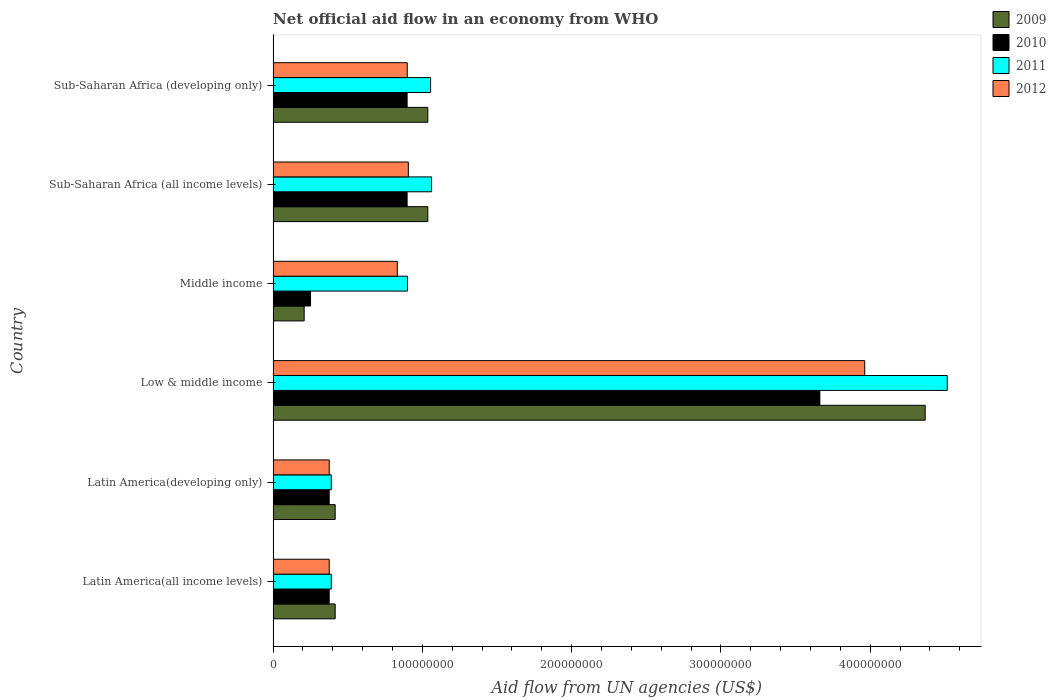How many different coloured bars are there?
Give a very brief answer. 4. How many groups of bars are there?
Ensure brevity in your answer.  6. Are the number of bars on each tick of the Y-axis equal?
Make the answer very short. Yes. How many bars are there on the 2nd tick from the bottom?
Your answer should be very brief. 4. What is the label of the 1st group of bars from the top?
Make the answer very short. Sub-Saharan Africa (developing only). What is the net official aid flow in 2010 in Latin America(developing only)?
Make the answer very short. 3.76e+07. Across all countries, what is the maximum net official aid flow in 2009?
Offer a very short reply. 4.37e+08. Across all countries, what is the minimum net official aid flow in 2010?
Ensure brevity in your answer.  2.51e+07. In which country was the net official aid flow in 2012 maximum?
Your response must be concise. Low & middle income. What is the total net official aid flow in 2010 in the graph?
Offer a very short reply. 6.46e+08. What is the difference between the net official aid flow in 2012 in Latin America(all income levels) and the net official aid flow in 2010 in Sub-Saharan Africa (developing only)?
Your answer should be very brief. -5.22e+07. What is the average net official aid flow in 2011 per country?
Offer a very short reply. 1.39e+08. What is the difference between the net official aid flow in 2011 and net official aid flow in 2009 in Latin America(developing only)?
Your response must be concise. -2.59e+06. In how many countries, is the net official aid flow in 2011 greater than 160000000 US$?
Your answer should be compact. 1. What is the ratio of the net official aid flow in 2009 in Latin America(all income levels) to that in Middle income?
Offer a terse response. 2. Is the net official aid flow in 2009 in Middle income less than that in Sub-Saharan Africa (all income levels)?
Provide a succinct answer. Yes. Is the difference between the net official aid flow in 2011 in Middle income and Sub-Saharan Africa (all income levels) greater than the difference between the net official aid flow in 2009 in Middle income and Sub-Saharan Africa (all income levels)?
Provide a succinct answer. Yes. What is the difference between the highest and the second highest net official aid flow in 2011?
Provide a succinct answer. 3.45e+08. What is the difference between the highest and the lowest net official aid flow in 2010?
Offer a terse response. 3.41e+08. Is it the case that in every country, the sum of the net official aid flow in 2009 and net official aid flow in 2010 is greater than the net official aid flow in 2012?
Your answer should be very brief. No. How many bars are there?
Offer a terse response. 24. Are all the bars in the graph horizontal?
Ensure brevity in your answer.  Yes. How many countries are there in the graph?
Provide a short and direct response. 6. What is the difference between two consecutive major ticks on the X-axis?
Provide a succinct answer. 1.00e+08. Are the values on the major ticks of X-axis written in scientific E-notation?
Give a very brief answer. No. Does the graph contain any zero values?
Ensure brevity in your answer.  No. Does the graph contain grids?
Provide a succinct answer. No. Where does the legend appear in the graph?
Your answer should be very brief. Top right. How many legend labels are there?
Provide a short and direct response. 4. How are the legend labels stacked?
Offer a terse response. Vertical. What is the title of the graph?
Give a very brief answer. Net official aid flow in an economy from WHO. Does "2006" appear as one of the legend labels in the graph?
Provide a short and direct response. No. What is the label or title of the X-axis?
Provide a short and direct response. Aid flow from UN agencies (US$). What is the label or title of the Y-axis?
Keep it short and to the point. Country. What is the Aid flow from UN agencies (US$) in 2009 in Latin America(all income levels)?
Make the answer very short. 4.16e+07. What is the Aid flow from UN agencies (US$) in 2010 in Latin America(all income levels)?
Your response must be concise. 3.76e+07. What is the Aid flow from UN agencies (US$) of 2011 in Latin America(all income levels)?
Give a very brief answer. 3.90e+07. What is the Aid flow from UN agencies (US$) in 2012 in Latin America(all income levels)?
Offer a terse response. 3.76e+07. What is the Aid flow from UN agencies (US$) in 2009 in Latin America(developing only)?
Keep it short and to the point. 4.16e+07. What is the Aid flow from UN agencies (US$) in 2010 in Latin America(developing only)?
Your answer should be compact. 3.76e+07. What is the Aid flow from UN agencies (US$) of 2011 in Latin America(developing only)?
Your answer should be very brief. 3.90e+07. What is the Aid flow from UN agencies (US$) of 2012 in Latin America(developing only)?
Offer a terse response. 3.76e+07. What is the Aid flow from UN agencies (US$) in 2009 in Low & middle income?
Your response must be concise. 4.37e+08. What is the Aid flow from UN agencies (US$) in 2010 in Low & middle income?
Keep it short and to the point. 3.66e+08. What is the Aid flow from UN agencies (US$) in 2011 in Low & middle income?
Keep it short and to the point. 4.52e+08. What is the Aid flow from UN agencies (US$) in 2012 in Low & middle income?
Provide a short and direct response. 3.96e+08. What is the Aid flow from UN agencies (US$) of 2009 in Middle income?
Provide a short and direct response. 2.08e+07. What is the Aid flow from UN agencies (US$) in 2010 in Middle income?
Offer a terse response. 2.51e+07. What is the Aid flow from UN agencies (US$) in 2011 in Middle income?
Give a very brief answer. 9.00e+07. What is the Aid flow from UN agencies (US$) in 2012 in Middle income?
Ensure brevity in your answer.  8.32e+07. What is the Aid flow from UN agencies (US$) in 2009 in Sub-Saharan Africa (all income levels)?
Keep it short and to the point. 1.04e+08. What is the Aid flow from UN agencies (US$) in 2010 in Sub-Saharan Africa (all income levels)?
Keep it short and to the point. 8.98e+07. What is the Aid flow from UN agencies (US$) of 2011 in Sub-Saharan Africa (all income levels)?
Your response must be concise. 1.06e+08. What is the Aid flow from UN agencies (US$) of 2012 in Sub-Saharan Africa (all income levels)?
Make the answer very short. 9.06e+07. What is the Aid flow from UN agencies (US$) of 2009 in Sub-Saharan Africa (developing only)?
Give a very brief answer. 1.04e+08. What is the Aid flow from UN agencies (US$) in 2010 in Sub-Saharan Africa (developing only)?
Your answer should be compact. 8.98e+07. What is the Aid flow from UN agencies (US$) in 2011 in Sub-Saharan Africa (developing only)?
Make the answer very short. 1.05e+08. What is the Aid flow from UN agencies (US$) in 2012 in Sub-Saharan Africa (developing only)?
Offer a very short reply. 8.98e+07. Across all countries, what is the maximum Aid flow from UN agencies (US$) in 2009?
Offer a very short reply. 4.37e+08. Across all countries, what is the maximum Aid flow from UN agencies (US$) of 2010?
Keep it short and to the point. 3.66e+08. Across all countries, what is the maximum Aid flow from UN agencies (US$) of 2011?
Your answer should be compact. 4.52e+08. Across all countries, what is the maximum Aid flow from UN agencies (US$) in 2012?
Provide a short and direct response. 3.96e+08. Across all countries, what is the minimum Aid flow from UN agencies (US$) of 2009?
Offer a very short reply. 2.08e+07. Across all countries, what is the minimum Aid flow from UN agencies (US$) in 2010?
Your answer should be compact. 2.51e+07. Across all countries, what is the minimum Aid flow from UN agencies (US$) of 2011?
Provide a short and direct response. 3.90e+07. Across all countries, what is the minimum Aid flow from UN agencies (US$) of 2012?
Your response must be concise. 3.76e+07. What is the total Aid flow from UN agencies (US$) of 2009 in the graph?
Your answer should be compact. 7.48e+08. What is the total Aid flow from UN agencies (US$) in 2010 in the graph?
Your response must be concise. 6.46e+08. What is the total Aid flow from UN agencies (US$) of 2011 in the graph?
Provide a short and direct response. 8.31e+08. What is the total Aid flow from UN agencies (US$) in 2012 in the graph?
Your answer should be very brief. 7.35e+08. What is the difference between the Aid flow from UN agencies (US$) of 2010 in Latin America(all income levels) and that in Latin America(developing only)?
Keep it short and to the point. 0. What is the difference between the Aid flow from UN agencies (US$) in 2012 in Latin America(all income levels) and that in Latin America(developing only)?
Offer a terse response. 0. What is the difference between the Aid flow from UN agencies (US$) in 2009 in Latin America(all income levels) and that in Low & middle income?
Make the answer very short. -3.95e+08. What is the difference between the Aid flow from UN agencies (US$) of 2010 in Latin America(all income levels) and that in Low & middle income?
Make the answer very short. -3.29e+08. What is the difference between the Aid flow from UN agencies (US$) in 2011 in Latin America(all income levels) and that in Low & middle income?
Offer a very short reply. -4.13e+08. What is the difference between the Aid flow from UN agencies (US$) in 2012 in Latin America(all income levels) and that in Low & middle income?
Your answer should be compact. -3.59e+08. What is the difference between the Aid flow from UN agencies (US$) of 2009 in Latin America(all income levels) and that in Middle income?
Provide a short and direct response. 2.08e+07. What is the difference between the Aid flow from UN agencies (US$) in 2010 in Latin America(all income levels) and that in Middle income?
Ensure brevity in your answer.  1.25e+07. What is the difference between the Aid flow from UN agencies (US$) of 2011 in Latin America(all income levels) and that in Middle income?
Give a very brief answer. -5.10e+07. What is the difference between the Aid flow from UN agencies (US$) in 2012 in Latin America(all income levels) and that in Middle income?
Your answer should be compact. -4.56e+07. What is the difference between the Aid flow from UN agencies (US$) of 2009 in Latin America(all income levels) and that in Sub-Saharan Africa (all income levels)?
Make the answer very short. -6.20e+07. What is the difference between the Aid flow from UN agencies (US$) in 2010 in Latin America(all income levels) and that in Sub-Saharan Africa (all income levels)?
Provide a succinct answer. -5.22e+07. What is the difference between the Aid flow from UN agencies (US$) in 2011 in Latin America(all income levels) and that in Sub-Saharan Africa (all income levels)?
Your response must be concise. -6.72e+07. What is the difference between the Aid flow from UN agencies (US$) of 2012 in Latin America(all income levels) and that in Sub-Saharan Africa (all income levels)?
Make the answer very short. -5.30e+07. What is the difference between the Aid flow from UN agencies (US$) in 2009 in Latin America(all income levels) and that in Sub-Saharan Africa (developing only)?
Offer a terse response. -6.20e+07. What is the difference between the Aid flow from UN agencies (US$) of 2010 in Latin America(all income levels) and that in Sub-Saharan Africa (developing only)?
Make the answer very short. -5.22e+07. What is the difference between the Aid flow from UN agencies (US$) of 2011 in Latin America(all income levels) and that in Sub-Saharan Africa (developing only)?
Provide a short and direct response. -6.65e+07. What is the difference between the Aid flow from UN agencies (US$) in 2012 in Latin America(all income levels) and that in Sub-Saharan Africa (developing only)?
Ensure brevity in your answer.  -5.23e+07. What is the difference between the Aid flow from UN agencies (US$) in 2009 in Latin America(developing only) and that in Low & middle income?
Provide a short and direct response. -3.95e+08. What is the difference between the Aid flow from UN agencies (US$) in 2010 in Latin America(developing only) and that in Low & middle income?
Your answer should be very brief. -3.29e+08. What is the difference between the Aid flow from UN agencies (US$) of 2011 in Latin America(developing only) and that in Low & middle income?
Keep it short and to the point. -4.13e+08. What is the difference between the Aid flow from UN agencies (US$) of 2012 in Latin America(developing only) and that in Low & middle income?
Provide a short and direct response. -3.59e+08. What is the difference between the Aid flow from UN agencies (US$) in 2009 in Latin America(developing only) and that in Middle income?
Provide a short and direct response. 2.08e+07. What is the difference between the Aid flow from UN agencies (US$) of 2010 in Latin America(developing only) and that in Middle income?
Ensure brevity in your answer.  1.25e+07. What is the difference between the Aid flow from UN agencies (US$) of 2011 in Latin America(developing only) and that in Middle income?
Give a very brief answer. -5.10e+07. What is the difference between the Aid flow from UN agencies (US$) of 2012 in Latin America(developing only) and that in Middle income?
Provide a short and direct response. -4.56e+07. What is the difference between the Aid flow from UN agencies (US$) of 2009 in Latin America(developing only) and that in Sub-Saharan Africa (all income levels)?
Keep it short and to the point. -6.20e+07. What is the difference between the Aid flow from UN agencies (US$) in 2010 in Latin America(developing only) and that in Sub-Saharan Africa (all income levels)?
Provide a short and direct response. -5.22e+07. What is the difference between the Aid flow from UN agencies (US$) of 2011 in Latin America(developing only) and that in Sub-Saharan Africa (all income levels)?
Make the answer very short. -6.72e+07. What is the difference between the Aid flow from UN agencies (US$) of 2012 in Latin America(developing only) and that in Sub-Saharan Africa (all income levels)?
Offer a terse response. -5.30e+07. What is the difference between the Aid flow from UN agencies (US$) of 2009 in Latin America(developing only) and that in Sub-Saharan Africa (developing only)?
Provide a succinct answer. -6.20e+07. What is the difference between the Aid flow from UN agencies (US$) in 2010 in Latin America(developing only) and that in Sub-Saharan Africa (developing only)?
Provide a succinct answer. -5.22e+07. What is the difference between the Aid flow from UN agencies (US$) of 2011 in Latin America(developing only) and that in Sub-Saharan Africa (developing only)?
Offer a terse response. -6.65e+07. What is the difference between the Aid flow from UN agencies (US$) of 2012 in Latin America(developing only) and that in Sub-Saharan Africa (developing only)?
Ensure brevity in your answer.  -5.23e+07. What is the difference between the Aid flow from UN agencies (US$) of 2009 in Low & middle income and that in Middle income?
Ensure brevity in your answer.  4.16e+08. What is the difference between the Aid flow from UN agencies (US$) in 2010 in Low & middle income and that in Middle income?
Ensure brevity in your answer.  3.41e+08. What is the difference between the Aid flow from UN agencies (US$) of 2011 in Low & middle income and that in Middle income?
Give a very brief answer. 3.62e+08. What is the difference between the Aid flow from UN agencies (US$) of 2012 in Low & middle income and that in Middle income?
Provide a succinct answer. 3.13e+08. What is the difference between the Aid flow from UN agencies (US$) in 2009 in Low & middle income and that in Sub-Saharan Africa (all income levels)?
Ensure brevity in your answer.  3.33e+08. What is the difference between the Aid flow from UN agencies (US$) of 2010 in Low & middle income and that in Sub-Saharan Africa (all income levels)?
Ensure brevity in your answer.  2.76e+08. What is the difference between the Aid flow from UN agencies (US$) in 2011 in Low & middle income and that in Sub-Saharan Africa (all income levels)?
Offer a very short reply. 3.45e+08. What is the difference between the Aid flow from UN agencies (US$) of 2012 in Low & middle income and that in Sub-Saharan Africa (all income levels)?
Ensure brevity in your answer.  3.06e+08. What is the difference between the Aid flow from UN agencies (US$) of 2009 in Low & middle income and that in Sub-Saharan Africa (developing only)?
Your answer should be very brief. 3.33e+08. What is the difference between the Aid flow from UN agencies (US$) of 2010 in Low & middle income and that in Sub-Saharan Africa (developing only)?
Offer a very short reply. 2.76e+08. What is the difference between the Aid flow from UN agencies (US$) of 2011 in Low & middle income and that in Sub-Saharan Africa (developing only)?
Give a very brief answer. 3.46e+08. What is the difference between the Aid flow from UN agencies (US$) in 2012 in Low & middle income and that in Sub-Saharan Africa (developing only)?
Keep it short and to the point. 3.06e+08. What is the difference between the Aid flow from UN agencies (US$) of 2009 in Middle income and that in Sub-Saharan Africa (all income levels)?
Provide a succinct answer. -8.28e+07. What is the difference between the Aid flow from UN agencies (US$) of 2010 in Middle income and that in Sub-Saharan Africa (all income levels)?
Provide a short and direct response. -6.47e+07. What is the difference between the Aid flow from UN agencies (US$) in 2011 in Middle income and that in Sub-Saharan Africa (all income levels)?
Your answer should be very brief. -1.62e+07. What is the difference between the Aid flow from UN agencies (US$) of 2012 in Middle income and that in Sub-Saharan Africa (all income levels)?
Make the answer very short. -7.39e+06. What is the difference between the Aid flow from UN agencies (US$) of 2009 in Middle income and that in Sub-Saharan Africa (developing only)?
Give a very brief answer. -8.28e+07. What is the difference between the Aid flow from UN agencies (US$) of 2010 in Middle income and that in Sub-Saharan Africa (developing only)?
Offer a terse response. -6.47e+07. What is the difference between the Aid flow from UN agencies (US$) in 2011 in Middle income and that in Sub-Saharan Africa (developing only)?
Provide a succinct answer. -1.55e+07. What is the difference between the Aid flow from UN agencies (US$) of 2012 in Middle income and that in Sub-Saharan Africa (developing only)?
Provide a short and direct response. -6.67e+06. What is the difference between the Aid flow from UN agencies (US$) in 2011 in Sub-Saharan Africa (all income levels) and that in Sub-Saharan Africa (developing only)?
Give a very brief answer. 6.70e+05. What is the difference between the Aid flow from UN agencies (US$) in 2012 in Sub-Saharan Africa (all income levels) and that in Sub-Saharan Africa (developing only)?
Ensure brevity in your answer.  7.20e+05. What is the difference between the Aid flow from UN agencies (US$) of 2009 in Latin America(all income levels) and the Aid flow from UN agencies (US$) of 2010 in Latin America(developing only)?
Give a very brief answer. 4.01e+06. What is the difference between the Aid flow from UN agencies (US$) in 2009 in Latin America(all income levels) and the Aid flow from UN agencies (US$) in 2011 in Latin America(developing only)?
Your answer should be compact. 2.59e+06. What is the difference between the Aid flow from UN agencies (US$) in 2009 in Latin America(all income levels) and the Aid flow from UN agencies (US$) in 2012 in Latin America(developing only)?
Offer a terse response. 3.99e+06. What is the difference between the Aid flow from UN agencies (US$) of 2010 in Latin America(all income levels) and the Aid flow from UN agencies (US$) of 2011 in Latin America(developing only)?
Your response must be concise. -1.42e+06. What is the difference between the Aid flow from UN agencies (US$) of 2011 in Latin America(all income levels) and the Aid flow from UN agencies (US$) of 2012 in Latin America(developing only)?
Your response must be concise. 1.40e+06. What is the difference between the Aid flow from UN agencies (US$) in 2009 in Latin America(all income levels) and the Aid flow from UN agencies (US$) in 2010 in Low & middle income?
Your response must be concise. -3.25e+08. What is the difference between the Aid flow from UN agencies (US$) in 2009 in Latin America(all income levels) and the Aid flow from UN agencies (US$) in 2011 in Low & middle income?
Offer a terse response. -4.10e+08. What is the difference between the Aid flow from UN agencies (US$) of 2009 in Latin America(all income levels) and the Aid flow from UN agencies (US$) of 2012 in Low & middle income?
Ensure brevity in your answer.  -3.55e+08. What is the difference between the Aid flow from UN agencies (US$) in 2010 in Latin America(all income levels) and the Aid flow from UN agencies (US$) in 2011 in Low & middle income?
Offer a terse response. -4.14e+08. What is the difference between the Aid flow from UN agencies (US$) of 2010 in Latin America(all income levels) and the Aid flow from UN agencies (US$) of 2012 in Low & middle income?
Offer a very short reply. -3.59e+08. What is the difference between the Aid flow from UN agencies (US$) of 2011 in Latin America(all income levels) and the Aid flow from UN agencies (US$) of 2012 in Low & middle income?
Your answer should be compact. -3.57e+08. What is the difference between the Aid flow from UN agencies (US$) in 2009 in Latin America(all income levels) and the Aid flow from UN agencies (US$) in 2010 in Middle income?
Ensure brevity in your answer.  1.65e+07. What is the difference between the Aid flow from UN agencies (US$) in 2009 in Latin America(all income levels) and the Aid flow from UN agencies (US$) in 2011 in Middle income?
Give a very brief answer. -4.84e+07. What is the difference between the Aid flow from UN agencies (US$) of 2009 in Latin America(all income levels) and the Aid flow from UN agencies (US$) of 2012 in Middle income?
Your response must be concise. -4.16e+07. What is the difference between the Aid flow from UN agencies (US$) of 2010 in Latin America(all income levels) and the Aid flow from UN agencies (US$) of 2011 in Middle income?
Your answer should be very brief. -5.24e+07. What is the difference between the Aid flow from UN agencies (US$) in 2010 in Latin America(all income levels) and the Aid flow from UN agencies (US$) in 2012 in Middle income?
Your answer should be compact. -4.56e+07. What is the difference between the Aid flow from UN agencies (US$) of 2011 in Latin America(all income levels) and the Aid flow from UN agencies (US$) of 2012 in Middle income?
Provide a short and direct response. -4.42e+07. What is the difference between the Aid flow from UN agencies (US$) in 2009 in Latin America(all income levels) and the Aid flow from UN agencies (US$) in 2010 in Sub-Saharan Africa (all income levels)?
Keep it short and to the point. -4.82e+07. What is the difference between the Aid flow from UN agencies (US$) of 2009 in Latin America(all income levels) and the Aid flow from UN agencies (US$) of 2011 in Sub-Saharan Africa (all income levels)?
Your response must be concise. -6.46e+07. What is the difference between the Aid flow from UN agencies (US$) in 2009 in Latin America(all income levels) and the Aid flow from UN agencies (US$) in 2012 in Sub-Saharan Africa (all income levels)?
Provide a short and direct response. -4.90e+07. What is the difference between the Aid flow from UN agencies (US$) of 2010 in Latin America(all income levels) and the Aid flow from UN agencies (US$) of 2011 in Sub-Saharan Africa (all income levels)?
Provide a short and direct response. -6.86e+07. What is the difference between the Aid flow from UN agencies (US$) of 2010 in Latin America(all income levels) and the Aid flow from UN agencies (US$) of 2012 in Sub-Saharan Africa (all income levels)?
Your response must be concise. -5.30e+07. What is the difference between the Aid flow from UN agencies (US$) in 2011 in Latin America(all income levels) and the Aid flow from UN agencies (US$) in 2012 in Sub-Saharan Africa (all income levels)?
Give a very brief answer. -5.16e+07. What is the difference between the Aid flow from UN agencies (US$) of 2009 in Latin America(all income levels) and the Aid flow from UN agencies (US$) of 2010 in Sub-Saharan Africa (developing only)?
Offer a very short reply. -4.82e+07. What is the difference between the Aid flow from UN agencies (US$) in 2009 in Latin America(all income levels) and the Aid flow from UN agencies (US$) in 2011 in Sub-Saharan Africa (developing only)?
Offer a terse response. -6.39e+07. What is the difference between the Aid flow from UN agencies (US$) of 2009 in Latin America(all income levels) and the Aid flow from UN agencies (US$) of 2012 in Sub-Saharan Africa (developing only)?
Provide a succinct answer. -4.83e+07. What is the difference between the Aid flow from UN agencies (US$) of 2010 in Latin America(all income levels) and the Aid flow from UN agencies (US$) of 2011 in Sub-Saharan Africa (developing only)?
Ensure brevity in your answer.  -6.79e+07. What is the difference between the Aid flow from UN agencies (US$) in 2010 in Latin America(all income levels) and the Aid flow from UN agencies (US$) in 2012 in Sub-Saharan Africa (developing only)?
Your answer should be compact. -5.23e+07. What is the difference between the Aid flow from UN agencies (US$) of 2011 in Latin America(all income levels) and the Aid flow from UN agencies (US$) of 2012 in Sub-Saharan Africa (developing only)?
Give a very brief answer. -5.09e+07. What is the difference between the Aid flow from UN agencies (US$) of 2009 in Latin America(developing only) and the Aid flow from UN agencies (US$) of 2010 in Low & middle income?
Keep it short and to the point. -3.25e+08. What is the difference between the Aid flow from UN agencies (US$) in 2009 in Latin America(developing only) and the Aid flow from UN agencies (US$) in 2011 in Low & middle income?
Make the answer very short. -4.10e+08. What is the difference between the Aid flow from UN agencies (US$) of 2009 in Latin America(developing only) and the Aid flow from UN agencies (US$) of 2012 in Low & middle income?
Provide a short and direct response. -3.55e+08. What is the difference between the Aid flow from UN agencies (US$) in 2010 in Latin America(developing only) and the Aid flow from UN agencies (US$) in 2011 in Low & middle income?
Offer a very short reply. -4.14e+08. What is the difference between the Aid flow from UN agencies (US$) in 2010 in Latin America(developing only) and the Aid flow from UN agencies (US$) in 2012 in Low & middle income?
Your response must be concise. -3.59e+08. What is the difference between the Aid flow from UN agencies (US$) in 2011 in Latin America(developing only) and the Aid flow from UN agencies (US$) in 2012 in Low & middle income?
Provide a short and direct response. -3.57e+08. What is the difference between the Aid flow from UN agencies (US$) in 2009 in Latin America(developing only) and the Aid flow from UN agencies (US$) in 2010 in Middle income?
Provide a succinct answer. 1.65e+07. What is the difference between the Aid flow from UN agencies (US$) in 2009 in Latin America(developing only) and the Aid flow from UN agencies (US$) in 2011 in Middle income?
Make the answer very short. -4.84e+07. What is the difference between the Aid flow from UN agencies (US$) in 2009 in Latin America(developing only) and the Aid flow from UN agencies (US$) in 2012 in Middle income?
Offer a terse response. -4.16e+07. What is the difference between the Aid flow from UN agencies (US$) in 2010 in Latin America(developing only) and the Aid flow from UN agencies (US$) in 2011 in Middle income?
Your answer should be compact. -5.24e+07. What is the difference between the Aid flow from UN agencies (US$) of 2010 in Latin America(developing only) and the Aid flow from UN agencies (US$) of 2012 in Middle income?
Offer a very short reply. -4.56e+07. What is the difference between the Aid flow from UN agencies (US$) in 2011 in Latin America(developing only) and the Aid flow from UN agencies (US$) in 2012 in Middle income?
Your answer should be compact. -4.42e+07. What is the difference between the Aid flow from UN agencies (US$) of 2009 in Latin America(developing only) and the Aid flow from UN agencies (US$) of 2010 in Sub-Saharan Africa (all income levels)?
Ensure brevity in your answer.  -4.82e+07. What is the difference between the Aid flow from UN agencies (US$) in 2009 in Latin America(developing only) and the Aid flow from UN agencies (US$) in 2011 in Sub-Saharan Africa (all income levels)?
Offer a very short reply. -6.46e+07. What is the difference between the Aid flow from UN agencies (US$) in 2009 in Latin America(developing only) and the Aid flow from UN agencies (US$) in 2012 in Sub-Saharan Africa (all income levels)?
Offer a very short reply. -4.90e+07. What is the difference between the Aid flow from UN agencies (US$) in 2010 in Latin America(developing only) and the Aid flow from UN agencies (US$) in 2011 in Sub-Saharan Africa (all income levels)?
Your answer should be compact. -6.86e+07. What is the difference between the Aid flow from UN agencies (US$) of 2010 in Latin America(developing only) and the Aid flow from UN agencies (US$) of 2012 in Sub-Saharan Africa (all income levels)?
Keep it short and to the point. -5.30e+07. What is the difference between the Aid flow from UN agencies (US$) of 2011 in Latin America(developing only) and the Aid flow from UN agencies (US$) of 2012 in Sub-Saharan Africa (all income levels)?
Offer a terse response. -5.16e+07. What is the difference between the Aid flow from UN agencies (US$) in 2009 in Latin America(developing only) and the Aid flow from UN agencies (US$) in 2010 in Sub-Saharan Africa (developing only)?
Make the answer very short. -4.82e+07. What is the difference between the Aid flow from UN agencies (US$) of 2009 in Latin America(developing only) and the Aid flow from UN agencies (US$) of 2011 in Sub-Saharan Africa (developing only)?
Keep it short and to the point. -6.39e+07. What is the difference between the Aid flow from UN agencies (US$) in 2009 in Latin America(developing only) and the Aid flow from UN agencies (US$) in 2012 in Sub-Saharan Africa (developing only)?
Provide a succinct answer. -4.83e+07. What is the difference between the Aid flow from UN agencies (US$) in 2010 in Latin America(developing only) and the Aid flow from UN agencies (US$) in 2011 in Sub-Saharan Africa (developing only)?
Give a very brief answer. -6.79e+07. What is the difference between the Aid flow from UN agencies (US$) of 2010 in Latin America(developing only) and the Aid flow from UN agencies (US$) of 2012 in Sub-Saharan Africa (developing only)?
Keep it short and to the point. -5.23e+07. What is the difference between the Aid flow from UN agencies (US$) of 2011 in Latin America(developing only) and the Aid flow from UN agencies (US$) of 2012 in Sub-Saharan Africa (developing only)?
Offer a very short reply. -5.09e+07. What is the difference between the Aid flow from UN agencies (US$) of 2009 in Low & middle income and the Aid flow from UN agencies (US$) of 2010 in Middle income?
Keep it short and to the point. 4.12e+08. What is the difference between the Aid flow from UN agencies (US$) of 2009 in Low & middle income and the Aid flow from UN agencies (US$) of 2011 in Middle income?
Your answer should be very brief. 3.47e+08. What is the difference between the Aid flow from UN agencies (US$) in 2009 in Low & middle income and the Aid flow from UN agencies (US$) in 2012 in Middle income?
Offer a terse response. 3.54e+08. What is the difference between the Aid flow from UN agencies (US$) in 2010 in Low & middle income and the Aid flow from UN agencies (US$) in 2011 in Middle income?
Make the answer very short. 2.76e+08. What is the difference between the Aid flow from UN agencies (US$) of 2010 in Low & middle income and the Aid flow from UN agencies (US$) of 2012 in Middle income?
Your answer should be compact. 2.83e+08. What is the difference between the Aid flow from UN agencies (US$) in 2011 in Low & middle income and the Aid flow from UN agencies (US$) in 2012 in Middle income?
Your answer should be very brief. 3.68e+08. What is the difference between the Aid flow from UN agencies (US$) in 2009 in Low & middle income and the Aid flow from UN agencies (US$) in 2010 in Sub-Saharan Africa (all income levels)?
Your answer should be very brief. 3.47e+08. What is the difference between the Aid flow from UN agencies (US$) in 2009 in Low & middle income and the Aid flow from UN agencies (US$) in 2011 in Sub-Saharan Africa (all income levels)?
Make the answer very short. 3.31e+08. What is the difference between the Aid flow from UN agencies (US$) in 2009 in Low & middle income and the Aid flow from UN agencies (US$) in 2012 in Sub-Saharan Africa (all income levels)?
Offer a very short reply. 3.46e+08. What is the difference between the Aid flow from UN agencies (US$) of 2010 in Low & middle income and the Aid flow from UN agencies (US$) of 2011 in Sub-Saharan Africa (all income levels)?
Keep it short and to the point. 2.60e+08. What is the difference between the Aid flow from UN agencies (US$) of 2010 in Low & middle income and the Aid flow from UN agencies (US$) of 2012 in Sub-Saharan Africa (all income levels)?
Your answer should be very brief. 2.76e+08. What is the difference between the Aid flow from UN agencies (US$) of 2011 in Low & middle income and the Aid flow from UN agencies (US$) of 2012 in Sub-Saharan Africa (all income levels)?
Make the answer very short. 3.61e+08. What is the difference between the Aid flow from UN agencies (US$) in 2009 in Low & middle income and the Aid flow from UN agencies (US$) in 2010 in Sub-Saharan Africa (developing only)?
Keep it short and to the point. 3.47e+08. What is the difference between the Aid flow from UN agencies (US$) in 2009 in Low & middle income and the Aid flow from UN agencies (US$) in 2011 in Sub-Saharan Africa (developing only)?
Offer a terse response. 3.31e+08. What is the difference between the Aid flow from UN agencies (US$) of 2009 in Low & middle income and the Aid flow from UN agencies (US$) of 2012 in Sub-Saharan Africa (developing only)?
Keep it short and to the point. 3.47e+08. What is the difference between the Aid flow from UN agencies (US$) of 2010 in Low & middle income and the Aid flow from UN agencies (US$) of 2011 in Sub-Saharan Africa (developing only)?
Give a very brief answer. 2.61e+08. What is the difference between the Aid flow from UN agencies (US$) in 2010 in Low & middle income and the Aid flow from UN agencies (US$) in 2012 in Sub-Saharan Africa (developing only)?
Provide a short and direct response. 2.76e+08. What is the difference between the Aid flow from UN agencies (US$) in 2011 in Low & middle income and the Aid flow from UN agencies (US$) in 2012 in Sub-Saharan Africa (developing only)?
Offer a terse response. 3.62e+08. What is the difference between the Aid flow from UN agencies (US$) of 2009 in Middle income and the Aid flow from UN agencies (US$) of 2010 in Sub-Saharan Africa (all income levels)?
Ensure brevity in your answer.  -6.90e+07. What is the difference between the Aid flow from UN agencies (US$) in 2009 in Middle income and the Aid flow from UN agencies (US$) in 2011 in Sub-Saharan Africa (all income levels)?
Your response must be concise. -8.54e+07. What is the difference between the Aid flow from UN agencies (US$) in 2009 in Middle income and the Aid flow from UN agencies (US$) in 2012 in Sub-Saharan Africa (all income levels)?
Give a very brief answer. -6.98e+07. What is the difference between the Aid flow from UN agencies (US$) in 2010 in Middle income and the Aid flow from UN agencies (US$) in 2011 in Sub-Saharan Africa (all income levels)?
Provide a succinct answer. -8.11e+07. What is the difference between the Aid flow from UN agencies (US$) in 2010 in Middle income and the Aid flow from UN agencies (US$) in 2012 in Sub-Saharan Africa (all income levels)?
Your response must be concise. -6.55e+07. What is the difference between the Aid flow from UN agencies (US$) of 2011 in Middle income and the Aid flow from UN agencies (US$) of 2012 in Sub-Saharan Africa (all income levels)?
Provide a short and direct response. -5.90e+05. What is the difference between the Aid flow from UN agencies (US$) of 2009 in Middle income and the Aid flow from UN agencies (US$) of 2010 in Sub-Saharan Africa (developing only)?
Give a very brief answer. -6.90e+07. What is the difference between the Aid flow from UN agencies (US$) in 2009 in Middle income and the Aid flow from UN agencies (US$) in 2011 in Sub-Saharan Africa (developing only)?
Ensure brevity in your answer.  -8.47e+07. What is the difference between the Aid flow from UN agencies (US$) of 2009 in Middle income and the Aid flow from UN agencies (US$) of 2012 in Sub-Saharan Africa (developing only)?
Give a very brief answer. -6.90e+07. What is the difference between the Aid flow from UN agencies (US$) of 2010 in Middle income and the Aid flow from UN agencies (US$) of 2011 in Sub-Saharan Africa (developing only)?
Make the answer very short. -8.04e+07. What is the difference between the Aid flow from UN agencies (US$) of 2010 in Middle income and the Aid flow from UN agencies (US$) of 2012 in Sub-Saharan Africa (developing only)?
Keep it short and to the point. -6.48e+07. What is the difference between the Aid flow from UN agencies (US$) in 2011 in Middle income and the Aid flow from UN agencies (US$) in 2012 in Sub-Saharan Africa (developing only)?
Provide a short and direct response. 1.30e+05. What is the difference between the Aid flow from UN agencies (US$) of 2009 in Sub-Saharan Africa (all income levels) and the Aid flow from UN agencies (US$) of 2010 in Sub-Saharan Africa (developing only)?
Keep it short and to the point. 1.39e+07. What is the difference between the Aid flow from UN agencies (US$) of 2009 in Sub-Saharan Africa (all income levels) and the Aid flow from UN agencies (US$) of 2011 in Sub-Saharan Africa (developing only)?
Ensure brevity in your answer.  -1.86e+06. What is the difference between the Aid flow from UN agencies (US$) in 2009 in Sub-Saharan Africa (all income levels) and the Aid flow from UN agencies (US$) in 2012 in Sub-Saharan Africa (developing only)?
Offer a terse response. 1.38e+07. What is the difference between the Aid flow from UN agencies (US$) of 2010 in Sub-Saharan Africa (all income levels) and the Aid flow from UN agencies (US$) of 2011 in Sub-Saharan Africa (developing only)?
Make the answer very short. -1.57e+07. What is the difference between the Aid flow from UN agencies (US$) in 2010 in Sub-Saharan Africa (all income levels) and the Aid flow from UN agencies (US$) in 2012 in Sub-Saharan Africa (developing only)?
Give a very brief answer. -9.00e+04. What is the difference between the Aid flow from UN agencies (US$) in 2011 in Sub-Saharan Africa (all income levels) and the Aid flow from UN agencies (US$) in 2012 in Sub-Saharan Africa (developing only)?
Offer a very short reply. 1.63e+07. What is the average Aid flow from UN agencies (US$) of 2009 per country?
Provide a short and direct response. 1.25e+08. What is the average Aid flow from UN agencies (US$) of 2010 per country?
Offer a very short reply. 1.08e+08. What is the average Aid flow from UN agencies (US$) in 2011 per country?
Ensure brevity in your answer.  1.39e+08. What is the average Aid flow from UN agencies (US$) of 2012 per country?
Provide a short and direct response. 1.23e+08. What is the difference between the Aid flow from UN agencies (US$) in 2009 and Aid flow from UN agencies (US$) in 2010 in Latin America(all income levels)?
Your answer should be compact. 4.01e+06. What is the difference between the Aid flow from UN agencies (US$) of 2009 and Aid flow from UN agencies (US$) of 2011 in Latin America(all income levels)?
Provide a succinct answer. 2.59e+06. What is the difference between the Aid flow from UN agencies (US$) of 2009 and Aid flow from UN agencies (US$) of 2012 in Latin America(all income levels)?
Provide a short and direct response. 3.99e+06. What is the difference between the Aid flow from UN agencies (US$) of 2010 and Aid flow from UN agencies (US$) of 2011 in Latin America(all income levels)?
Ensure brevity in your answer.  -1.42e+06. What is the difference between the Aid flow from UN agencies (US$) of 2010 and Aid flow from UN agencies (US$) of 2012 in Latin America(all income levels)?
Your response must be concise. -2.00e+04. What is the difference between the Aid flow from UN agencies (US$) in 2011 and Aid flow from UN agencies (US$) in 2012 in Latin America(all income levels)?
Offer a terse response. 1.40e+06. What is the difference between the Aid flow from UN agencies (US$) in 2009 and Aid flow from UN agencies (US$) in 2010 in Latin America(developing only)?
Provide a succinct answer. 4.01e+06. What is the difference between the Aid flow from UN agencies (US$) in 2009 and Aid flow from UN agencies (US$) in 2011 in Latin America(developing only)?
Keep it short and to the point. 2.59e+06. What is the difference between the Aid flow from UN agencies (US$) in 2009 and Aid flow from UN agencies (US$) in 2012 in Latin America(developing only)?
Offer a terse response. 3.99e+06. What is the difference between the Aid flow from UN agencies (US$) in 2010 and Aid flow from UN agencies (US$) in 2011 in Latin America(developing only)?
Offer a terse response. -1.42e+06. What is the difference between the Aid flow from UN agencies (US$) of 2010 and Aid flow from UN agencies (US$) of 2012 in Latin America(developing only)?
Offer a terse response. -2.00e+04. What is the difference between the Aid flow from UN agencies (US$) of 2011 and Aid flow from UN agencies (US$) of 2012 in Latin America(developing only)?
Provide a short and direct response. 1.40e+06. What is the difference between the Aid flow from UN agencies (US$) of 2009 and Aid flow from UN agencies (US$) of 2010 in Low & middle income?
Your answer should be very brief. 7.06e+07. What is the difference between the Aid flow from UN agencies (US$) in 2009 and Aid flow from UN agencies (US$) in 2011 in Low & middle income?
Offer a very short reply. -1.48e+07. What is the difference between the Aid flow from UN agencies (US$) in 2009 and Aid flow from UN agencies (US$) in 2012 in Low & middle income?
Your answer should be very brief. 4.05e+07. What is the difference between the Aid flow from UN agencies (US$) in 2010 and Aid flow from UN agencies (US$) in 2011 in Low & middle income?
Your response must be concise. -8.54e+07. What is the difference between the Aid flow from UN agencies (US$) of 2010 and Aid flow from UN agencies (US$) of 2012 in Low & middle income?
Your answer should be compact. -3.00e+07. What is the difference between the Aid flow from UN agencies (US$) in 2011 and Aid flow from UN agencies (US$) in 2012 in Low & middle income?
Provide a succinct answer. 5.53e+07. What is the difference between the Aid flow from UN agencies (US$) in 2009 and Aid flow from UN agencies (US$) in 2010 in Middle income?
Make the answer very short. -4.27e+06. What is the difference between the Aid flow from UN agencies (US$) in 2009 and Aid flow from UN agencies (US$) in 2011 in Middle income?
Your answer should be compact. -6.92e+07. What is the difference between the Aid flow from UN agencies (US$) in 2009 and Aid flow from UN agencies (US$) in 2012 in Middle income?
Provide a short and direct response. -6.24e+07. What is the difference between the Aid flow from UN agencies (US$) of 2010 and Aid flow from UN agencies (US$) of 2011 in Middle income?
Provide a short and direct response. -6.49e+07. What is the difference between the Aid flow from UN agencies (US$) of 2010 and Aid flow from UN agencies (US$) of 2012 in Middle income?
Give a very brief answer. -5.81e+07. What is the difference between the Aid flow from UN agencies (US$) of 2011 and Aid flow from UN agencies (US$) of 2012 in Middle income?
Offer a terse response. 6.80e+06. What is the difference between the Aid flow from UN agencies (US$) in 2009 and Aid flow from UN agencies (US$) in 2010 in Sub-Saharan Africa (all income levels)?
Your response must be concise. 1.39e+07. What is the difference between the Aid flow from UN agencies (US$) in 2009 and Aid flow from UN agencies (US$) in 2011 in Sub-Saharan Africa (all income levels)?
Ensure brevity in your answer.  -2.53e+06. What is the difference between the Aid flow from UN agencies (US$) in 2009 and Aid flow from UN agencies (US$) in 2012 in Sub-Saharan Africa (all income levels)?
Your response must be concise. 1.30e+07. What is the difference between the Aid flow from UN agencies (US$) of 2010 and Aid flow from UN agencies (US$) of 2011 in Sub-Saharan Africa (all income levels)?
Your answer should be very brief. -1.64e+07. What is the difference between the Aid flow from UN agencies (US$) of 2010 and Aid flow from UN agencies (US$) of 2012 in Sub-Saharan Africa (all income levels)?
Ensure brevity in your answer.  -8.10e+05. What is the difference between the Aid flow from UN agencies (US$) in 2011 and Aid flow from UN agencies (US$) in 2012 in Sub-Saharan Africa (all income levels)?
Keep it short and to the point. 1.56e+07. What is the difference between the Aid flow from UN agencies (US$) of 2009 and Aid flow from UN agencies (US$) of 2010 in Sub-Saharan Africa (developing only)?
Ensure brevity in your answer.  1.39e+07. What is the difference between the Aid flow from UN agencies (US$) in 2009 and Aid flow from UN agencies (US$) in 2011 in Sub-Saharan Africa (developing only)?
Keep it short and to the point. -1.86e+06. What is the difference between the Aid flow from UN agencies (US$) of 2009 and Aid flow from UN agencies (US$) of 2012 in Sub-Saharan Africa (developing only)?
Your response must be concise. 1.38e+07. What is the difference between the Aid flow from UN agencies (US$) in 2010 and Aid flow from UN agencies (US$) in 2011 in Sub-Saharan Africa (developing only)?
Make the answer very short. -1.57e+07. What is the difference between the Aid flow from UN agencies (US$) of 2010 and Aid flow from UN agencies (US$) of 2012 in Sub-Saharan Africa (developing only)?
Offer a very short reply. -9.00e+04. What is the difference between the Aid flow from UN agencies (US$) in 2011 and Aid flow from UN agencies (US$) in 2012 in Sub-Saharan Africa (developing only)?
Your answer should be compact. 1.56e+07. What is the ratio of the Aid flow from UN agencies (US$) in 2010 in Latin America(all income levels) to that in Latin America(developing only)?
Give a very brief answer. 1. What is the ratio of the Aid flow from UN agencies (US$) in 2009 in Latin America(all income levels) to that in Low & middle income?
Your answer should be compact. 0.1. What is the ratio of the Aid flow from UN agencies (US$) of 2010 in Latin America(all income levels) to that in Low & middle income?
Provide a short and direct response. 0.1. What is the ratio of the Aid flow from UN agencies (US$) of 2011 in Latin America(all income levels) to that in Low & middle income?
Keep it short and to the point. 0.09. What is the ratio of the Aid flow from UN agencies (US$) of 2012 in Latin America(all income levels) to that in Low & middle income?
Offer a terse response. 0.09. What is the ratio of the Aid flow from UN agencies (US$) of 2009 in Latin America(all income levels) to that in Middle income?
Ensure brevity in your answer.  2. What is the ratio of the Aid flow from UN agencies (US$) in 2010 in Latin America(all income levels) to that in Middle income?
Provide a short and direct response. 1.5. What is the ratio of the Aid flow from UN agencies (US$) of 2011 in Latin America(all income levels) to that in Middle income?
Your response must be concise. 0.43. What is the ratio of the Aid flow from UN agencies (US$) of 2012 in Latin America(all income levels) to that in Middle income?
Provide a short and direct response. 0.45. What is the ratio of the Aid flow from UN agencies (US$) in 2009 in Latin America(all income levels) to that in Sub-Saharan Africa (all income levels)?
Offer a very short reply. 0.4. What is the ratio of the Aid flow from UN agencies (US$) in 2010 in Latin America(all income levels) to that in Sub-Saharan Africa (all income levels)?
Make the answer very short. 0.42. What is the ratio of the Aid flow from UN agencies (US$) in 2011 in Latin America(all income levels) to that in Sub-Saharan Africa (all income levels)?
Provide a short and direct response. 0.37. What is the ratio of the Aid flow from UN agencies (US$) of 2012 in Latin America(all income levels) to that in Sub-Saharan Africa (all income levels)?
Your answer should be compact. 0.41. What is the ratio of the Aid flow from UN agencies (US$) in 2009 in Latin America(all income levels) to that in Sub-Saharan Africa (developing only)?
Give a very brief answer. 0.4. What is the ratio of the Aid flow from UN agencies (US$) in 2010 in Latin America(all income levels) to that in Sub-Saharan Africa (developing only)?
Keep it short and to the point. 0.42. What is the ratio of the Aid flow from UN agencies (US$) in 2011 in Latin America(all income levels) to that in Sub-Saharan Africa (developing only)?
Offer a terse response. 0.37. What is the ratio of the Aid flow from UN agencies (US$) in 2012 in Latin America(all income levels) to that in Sub-Saharan Africa (developing only)?
Provide a short and direct response. 0.42. What is the ratio of the Aid flow from UN agencies (US$) of 2009 in Latin America(developing only) to that in Low & middle income?
Provide a short and direct response. 0.1. What is the ratio of the Aid flow from UN agencies (US$) in 2010 in Latin America(developing only) to that in Low & middle income?
Offer a very short reply. 0.1. What is the ratio of the Aid flow from UN agencies (US$) of 2011 in Latin America(developing only) to that in Low & middle income?
Your response must be concise. 0.09. What is the ratio of the Aid flow from UN agencies (US$) of 2012 in Latin America(developing only) to that in Low & middle income?
Your answer should be compact. 0.09. What is the ratio of the Aid flow from UN agencies (US$) of 2009 in Latin America(developing only) to that in Middle income?
Provide a succinct answer. 2. What is the ratio of the Aid flow from UN agencies (US$) in 2010 in Latin America(developing only) to that in Middle income?
Your answer should be very brief. 1.5. What is the ratio of the Aid flow from UN agencies (US$) in 2011 in Latin America(developing only) to that in Middle income?
Your answer should be very brief. 0.43. What is the ratio of the Aid flow from UN agencies (US$) of 2012 in Latin America(developing only) to that in Middle income?
Offer a terse response. 0.45. What is the ratio of the Aid flow from UN agencies (US$) of 2009 in Latin America(developing only) to that in Sub-Saharan Africa (all income levels)?
Give a very brief answer. 0.4. What is the ratio of the Aid flow from UN agencies (US$) of 2010 in Latin America(developing only) to that in Sub-Saharan Africa (all income levels)?
Make the answer very short. 0.42. What is the ratio of the Aid flow from UN agencies (US$) in 2011 in Latin America(developing only) to that in Sub-Saharan Africa (all income levels)?
Provide a short and direct response. 0.37. What is the ratio of the Aid flow from UN agencies (US$) in 2012 in Latin America(developing only) to that in Sub-Saharan Africa (all income levels)?
Your answer should be very brief. 0.41. What is the ratio of the Aid flow from UN agencies (US$) in 2009 in Latin America(developing only) to that in Sub-Saharan Africa (developing only)?
Make the answer very short. 0.4. What is the ratio of the Aid flow from UN agencies (US$) of 2010 in Latin America(developing only) to that in Sub-Saharan Africa (developing only)?
Offer a terse response. 0.42. What is the ratio of the Aid flow from UN agencies (US$) of 2011 in Latin America(developing only) to that in Sub-Saharan Africa (developing only)?
Offer a very short reply. 0.37. What is the ratio of the Aid flow from UN agencies (US$) in 2012 in Latin America(developing only) to that in Sub-Saharan Africa (developing only)?
Your answer should be very brief. 0.42. What is the ratio of the Aid flow from UN agencies (US$) in 2009 in Low & middle income to that in Middle income?
Provide a succinct answer. 21. What is the ratio of the Aid flow from UN agencies (US$) in 2010 in Low & middle income to that in Middle income?
Offer a terse response. 14.61. What is the ratio of the Aid flow from UN agencies (US$) in 2011 in Low & middle income to that in Middle income?
Your response must be concise. 5.02. What is the ratio of the Aid flow from UN agencies (US$) in 2012 in Low & middle income to that in Middle income?
Give a very brief answer. 4.76. What is the ratio of the Aid flow from UN agencies (US$) in 2009 in Low & middle income to that in Sub-Saharan Africa (all income levels)?
Offer a terse response. 4.22. What is the ratio of the Aid flow from UN agencies (US$) in 2010 in Low & middle income to that in Sub-Saharan Africa (all income levels)?
Your answer should be very brief. 4.08. What is the ratio of the Aid flow from UN agencies (US$) in 2011 in Low & middle income to that in Sub-Saharan Africa (all income levels)?
Make the answer very short. 4.25. What is the ratio of the Aid flow from UN agencies (US$) in 2012 in Low & middle income to that in Sub-Saharan Africa (all income levels)?
Provide a short and direct response. 4.38. What is the ratio of the Aid flow from UN agencies (US$) of 2009 in Low & middle income to that in Sub-Saharan Africa (developing only)?
Ensure brevity in your answer.  4.22. What is the ratio of the Aid flow from UN agencies (US$) in 2010 in Low & middle income to that in Sub-Saharan Africa (developing only)?
Keep it short and to the point. 4.08. What is the ratio of the Aid flow from UN agencies (US$) of 2011 in Low & middle income to that in Sub-Saharan Africa (developing only)?
Your answer should be very brief. 4.28. What is the ratio of the Aid flow from UN agencies (US$) of 2012 in Low & middle income to that in Sub-Saharan Africa (developing only)?
Make the answer very short. 4.41. What is the ratio of the Aid flow from UN agencies (US$) in 2009 in Middle income to that in Sub-Saharan Africa (all income levels)?
Provide a succinct answer. 0.2. What is the ratio of the Aid flow from UN agencies (US$) of 2010 in Middle income to that in Sub-Saharan Africa (all income levels)?
Offer a terse response. 0.28. What is the ratio of the Aid flow from UN agencies (US$) of 2011 in Middle income to that in Sub-Saharan Africa (all income levels)?
Keep it short and to the point. 0.85. What is the ratio of the Aid flow from UN agencies (US$) in 2012 in Middle income to that in Sub-Saharan Africa (all income levels)?
Offer a terse response. 0.92. What is the ratio of the Aid flow from UN agencies (US$) of 2009 in Middle income to that in Sub-Saharan Africa (developing only)?
Ensure brevity in your answer.  0.2. What is the ratio of the Aid flow from UN agencies (US$) in 2010 in Middle income to that in Sub-Saharan Africa (developing only)?
Your answer should be compact. 0.28. What is the ratio of the Aid flow from UN agencies (US$) of 2011 in Middle income to that in Sub-Saharan Africa (developing only)?
Offer a terse response. 0.85. What is the ratio of the Aid flow from UN agencies (US$) in 2012 in Middle income to that in Sub-Saharan Africa (developing only)?
Provide a short and direct response. 0.93. What is the ratio of the Aid flow from UN agencies (US$) of 2009 in Sub-Saharan Africa (all income levels) to that in Sub-Saharan Africa (developing only)?
Provide a succinct answer. 1. What is the ratio of the Aid flow from UN agencies (US$) in 2010 in Sub-Saharan Africa (all income levels) to that in Sub-Saharan Africa (developing only)?
Your answer should be very brief. 1. What is the ratio of the Aid flow from UN agencies (US$) of 2011 in Sub-Saharan Africa (all income levels) to that in Sub-Saharan Africa (developing only)?
Your answer should be compact. 1.01. What is the ratio of the Aid flow from UN agencies (US$) in 2012 in Sub-Saharan Africa (all income levels) to that in Sub-Saharan Africa (developing only)?
Your answer should be very brief. 1.01. What is the difference between the highest and the second highest Aid flow from UN agencies (US$) of 2009?
Make the answer very short. 3.33e+08. What is the difference between the highest and the second highest Aid flow from UN agencies (US$) in 2010?
Offer a very short reply. 2.76e+08. What is the difference between the highest and the second highest Aid flow from UN agencies (US$) in 2011?
Give a very brief answer. 3.45e+08. What is the difference between the highest and the second highest Aid flow from UN agencies (US$) of 2012?
Keep it short and to the point. 3.06e+08. What is the difference between the highest and the lowest Aid flow from UN agencies (US$) in 2009?
Your answer should be very brief. 4.16e+08. What is the difference between the highest and the lowest Aid flow from UN agencies (US$) of 2010?
Your answer should be compact. 3.41e+08. What is the difference between the highest and the lowest Aid flow from UN agencies (US$) of 2011?
Offer a very short reply. 4.13e+08. What is the difference between the highest and the lowest Aid flow from UN agencies (US$) of 2012?
Ensure brevity in your answer.  3.59e+08. 